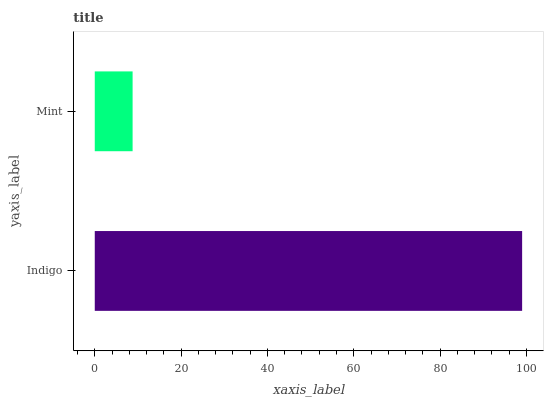Is Mint the minimum?
Answer yes or no. Yes. Is Indigo the maximum?
Answer yes or no. Yes. Is Mint the maximum?
Answer yes or no. No. Is Indigo greater than Mint?
Answer yes or no. Yes. Is Mint less than Indigo?
Answer yes or no. Yes. Is Mint greater than Indigo?
Answer yes or no. No. Is Indigo less than Mint?
Answer yes or no. No. Is Indigo the high median?
Answer yes or no. Yes. Is Mint the low median?
Answer yes or no. Yes. Is Mint the high median?
Answer yes or no. No. Is Indigo the low median?
Answer yes or no. No. 